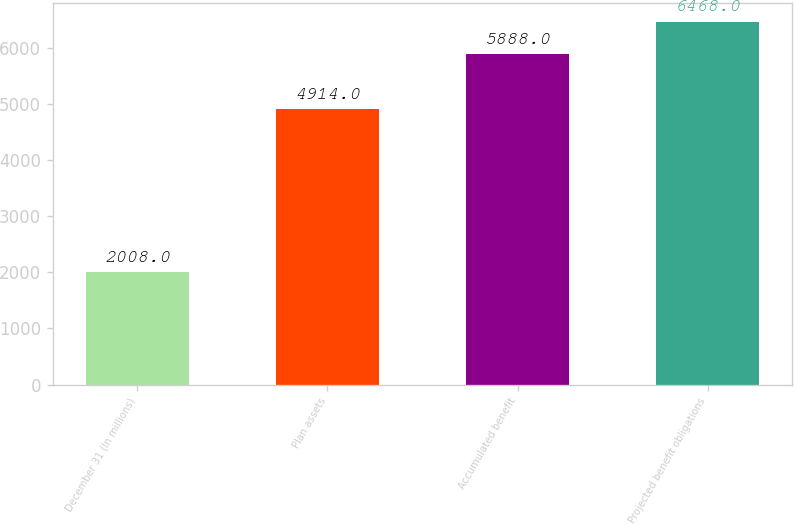Convert chart to OTSL. <chart><loc_0><loc_0><loc_500><loc_500><bar_chart><fcel>December 31 (In millions)<fcel>Plan assets<fcel>Accumulated benefit<fcel>Projected benefit obligations<nl><fcel>2008<fcel>4914<fcel>5888<fcel>6468<nl></chart> 